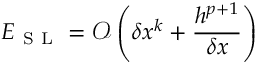<formula> <loc_0><loc_0><loc_500><loc_500>E _ { S L } = \mathcal { O } \left ( \delta x ^ { k } + \frac { h ^ { p + 1 } } { \delta x } \right )</formula> 